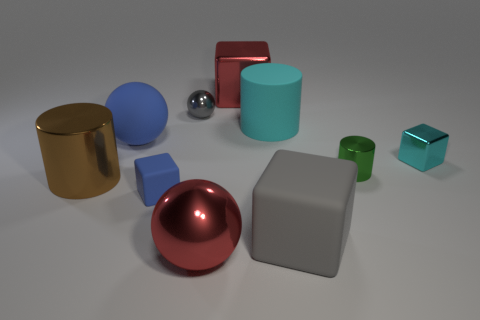There is a cyan shiny thing that is the same shape as the tiny blue rubber thing; what is its size?
Your answer should be compact. Small. Does the big shiny sphere have the same color as the big shiny block?
Your answer should be compact. Yes. How many blue cubes are to the right of the big gray matte thing that is on the right side of the big cylinder that is right of the brown cylinder?
Make the answer very short. 0. Is the number of tiny blue things greater than the number of big purple matte blocks?
Offer a terse response. Yes. How many small metallic objects are there?
Ensure brevity in your answer.  3. The large red metallic object in front of the big gray matte thing that is on the right side of the object that is on the left side of the large blue thing is what shape?
Your response must be concise. Sphere. Is the number of small balls that are behind the red block less than the number of rubber cubes on the left side of the large cyan thing?
Offer a terse response. Yes. There is a blue object behind the green metal cylinder; is it the same shape as the gray thing behind the blue rubber block?
Offer a very short reply. Yes. What shape is the red shiny thing in front of the large red thing that is behind the cyan block?
Your answer should be compact. Sphere. What size is the metallic ball that is the same color as the big rubber cube?
Your answer should be compact. Small. 